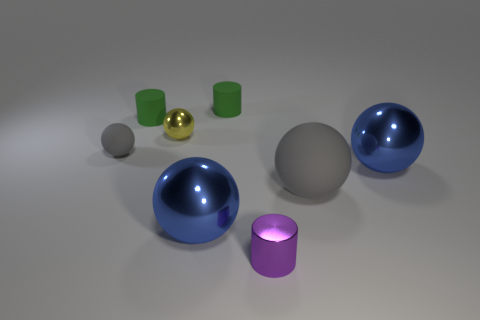Subtract 1 balls. How many balls are left? 4 Subtract all yellow balls. How many balls are left? 4 Subtract all tiny rubber spheres. How many spheres are left? 4 Subtract all red balls. Subtract all cyan cylinders. How many balls are left? 5 Add 1 yellow matte cylinders. How many objects exist? 9 Subtract all balls. How many objects are left? 3 Subtract 0 blue cubes. How many objects are left? 8 Subtract all small cyan rubber cubes. Subtract all large metal spheres. How many objects are left? 6 Add 4 matte cylinders. How many matte cylinders are left? 6 Add 8 big cyan metal objects. How many big cyan metal objects exist? 8 